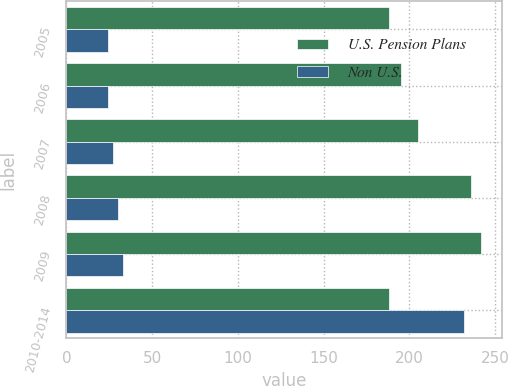Convert chart to OTSL. <chart><loc_0><loc_0><loc_500><loc_500><stacked_bar_chart><ecel><fcel>2005<fcel>2006<fcel>2007<fcel>2008<fcel>2009<fcel>2010-2014<nl><fcel>U.S. Pension Plans<fcel>188<fcel>195<fcel>205<fcel>236<fcel>242<fcel>188<nl><fcel>Non U.S.<fcel>24<fcel>24<fcel>27<fcel>30<fcel>33<fcel>232<nl></chart> 